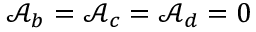Convert formula to latex. <formula><loc_0><loc_0><loc_500><loc_500>\mathcal { A } _ { b } = \mathcal { A } _ { c } = \mathcal { A } _ { d } = 0</formula> 